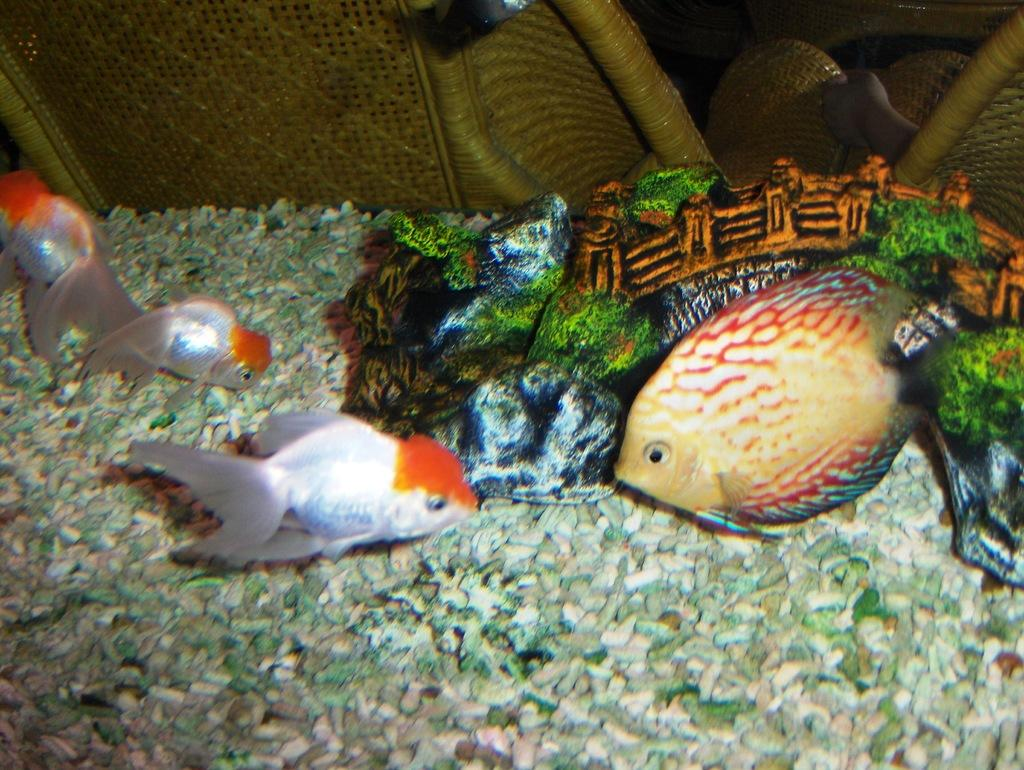What types of animals can be seen in the image? There are different types of fishes in the image. Where are the fishes located? The fishes are in an aquarium. What type of wool can be seen in the image? There is no wool present in the image; it features different types of fishes in an aquarium. 